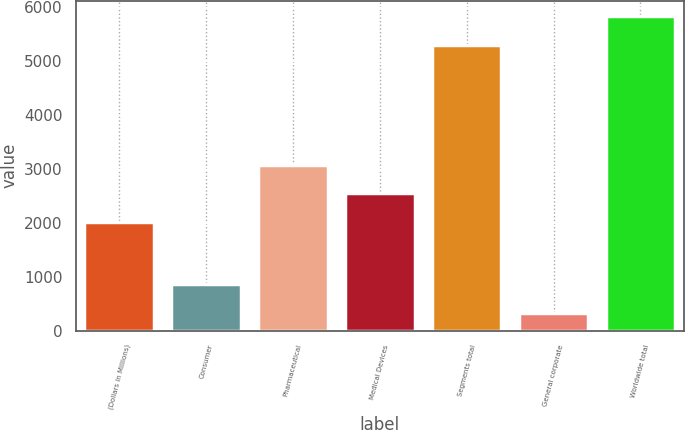<chart> <loc_0><loc_0><loc_500><loc_500><bar_chart><fcel>(Dollars in Millions)<fcel>Consumer<fcel>Pharmaceutical<fcel>Medical Devices<fcel>Segments total<fcel>General corporate<fcel>Worldwide total<nl><fcel>2017<fcel>866.6<fcel>3078.2<fcel>2547.6<fcel>5306<fcel>336<fcel>5836.6<nl></chart> 